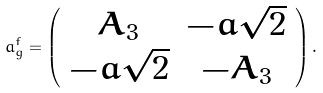Convert formula to latex. <formula><loc_0><loc_0><loc_500><loc_500>a ^ { \bar { f } } _ { \bar { g } } = \left ( \begin{array} { c c } A _ { 3 } & - \bar { a } \sqrt { 2 } \\ - a \sqrt { 2 } & - A _ { 3 } \end{array} \right ) .</formula> 